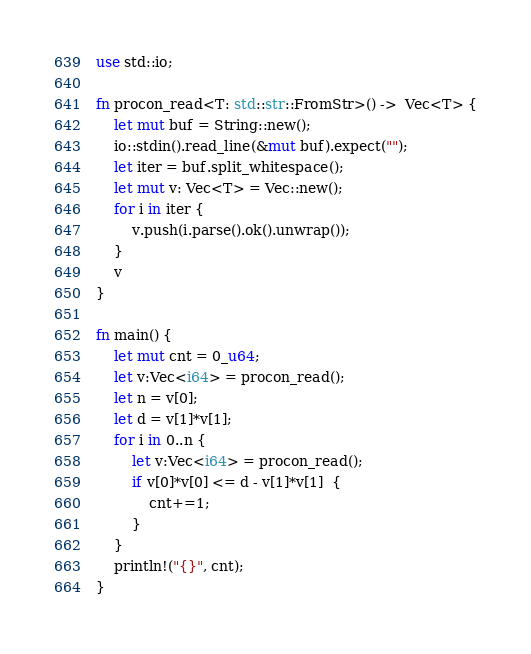<code> <loc_0><loc_0><loc_500><loc_500><_Rust_>use std::io;

fn procon_read<T: std::str::FromStr>() ->  Vec<T> {
    let mut buf = String::new();
    io::stdin().read_line(&mut buf).expect("");
    let iter = buf.split_whitespace();
    let mut v: Vec<T> = Vec::new();
    for i in iter {
        v.push(i.parse().ok().unwrap());
    }
    v
}

fn main() {
    let mut cnt = 0_u64;
    let v:Vec<i64> = procon_read();
    let n = v[0];
    let d = v[1]*v[1];
    for i in 0..n {
        let v:Vec<i64> = procon_read();
        if v[0]*v[0] <= d - v[1]*v[1]  {
            cnt+=1;
        }
    }
    println!("{}", cnt);
}</code> 